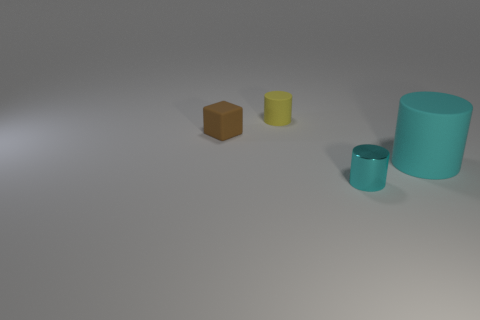Does the small cube have the same color as the shiny cylinder?
Provide a succinct answer. No. What size is the cylinder that is the same color as the small shiny object?
Offer a terse response. Large. Are there any cyan shiny things that are on the right side of the cyan thing that is on the right side of the tiny cylinder in front of the tiny matte block?
Keep it short and to the point. No. What number of rubber objects are in front of the yellow rubber cylinder?
Your answer should be compact. 2. What number of other small cylinders have the same color as the tiny metallic cylinder?
Ensure brevity in your answer.  0. How many objects are either things that are behind the metallic thing or cylinders in front of the tiny matte cylinder?
Your answer should be compact. 4. Is the number of green matte cylinders greater than the number of rubber cylinders?
Offer a very short reply. No. The tiny thing in front of the cyan matte cylinder is what color?
Offer a terse response. Cyan. Do the tiny cyan thing and the brown matte object have the same shape?
Make the answer very short. No. There is a thing that is behind the shiny cylinder and in front of the tiny brown cube; what color is it?
Make the answer very short. Cyan. 